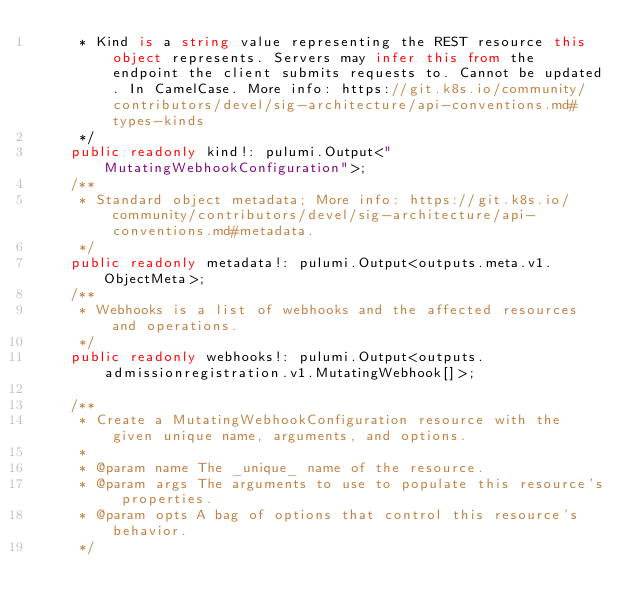Convert code to text. <code><loc_0><loc_0><loc_500><loc_500><_TypeScript_>     * Kind is a string value representing the REST resource this object represents. Servers may infer this from the endpoint the client submits requests to. Cannot be updated. In CamelCase. More info: https://git.k8s.io/community/contributors/devel/sig-architecture/api-conventions.md#types-kinds
     */
    public readonly kind!: pulumi.Output<"MutatingWebhookConfiguration">;
    /**
     * Standard object metadata; More info: https://git.k8s.io/community/contributors/devel/sig-architecture/api-conventions.md#metadata.
     */
    public readonly metadata!: pulumi.Output<outputs.meta.v1.ObjectMeta>;
    /**
     * Webhooks is a list of webhooks and the affected resources and operations.
     */
    public readonly webhooks!: pulumi.Output<outputs.admissionregistration.v1.MutatingWebhook[]>;

    /**
     * Create a MutatingWebhookConfiguration resource with the given unique name, arguments, and options.
     *
     * @param name The _unique_ name of the resource.
     * @param args The arguments to use to populate this resource's properties.
     * @param opts A bag of options that control this resource's behavior.
     */</code> 